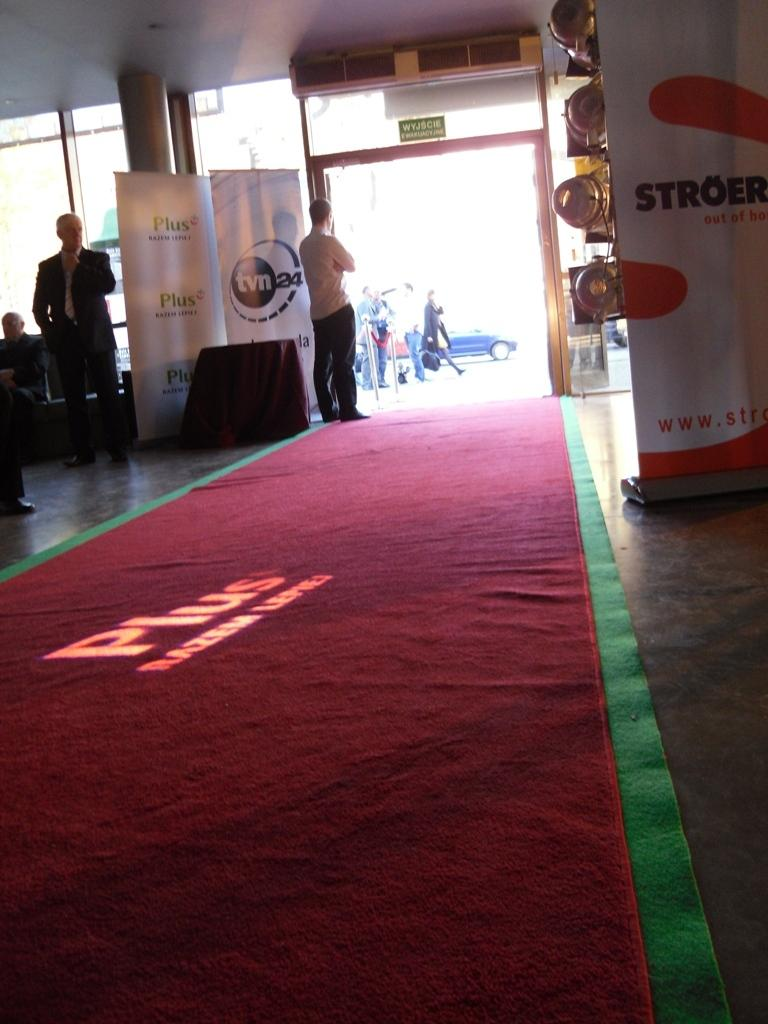What is at the bottom of the image? There is a red mat at the bottom of the image. What can be seen in the middle of the image? There is an entrance in the middle of the image. Where is the man located in the image? The man is standing on the left side of the image. What is the man wearing on his upper body? The man is wearing a coat. What is the man wearing on his lower body? The man is wearing trousers. Can you tell me how many snakes are slithering on the red mat in the image? There are no snakes present in the image; it features a red mat, an entrance, and a man wearing a coat and trousers. What historical event is depicted in the image? There is no historical event depicted in the image; it is a simple scene with a red mat, an entrance, and a man. 